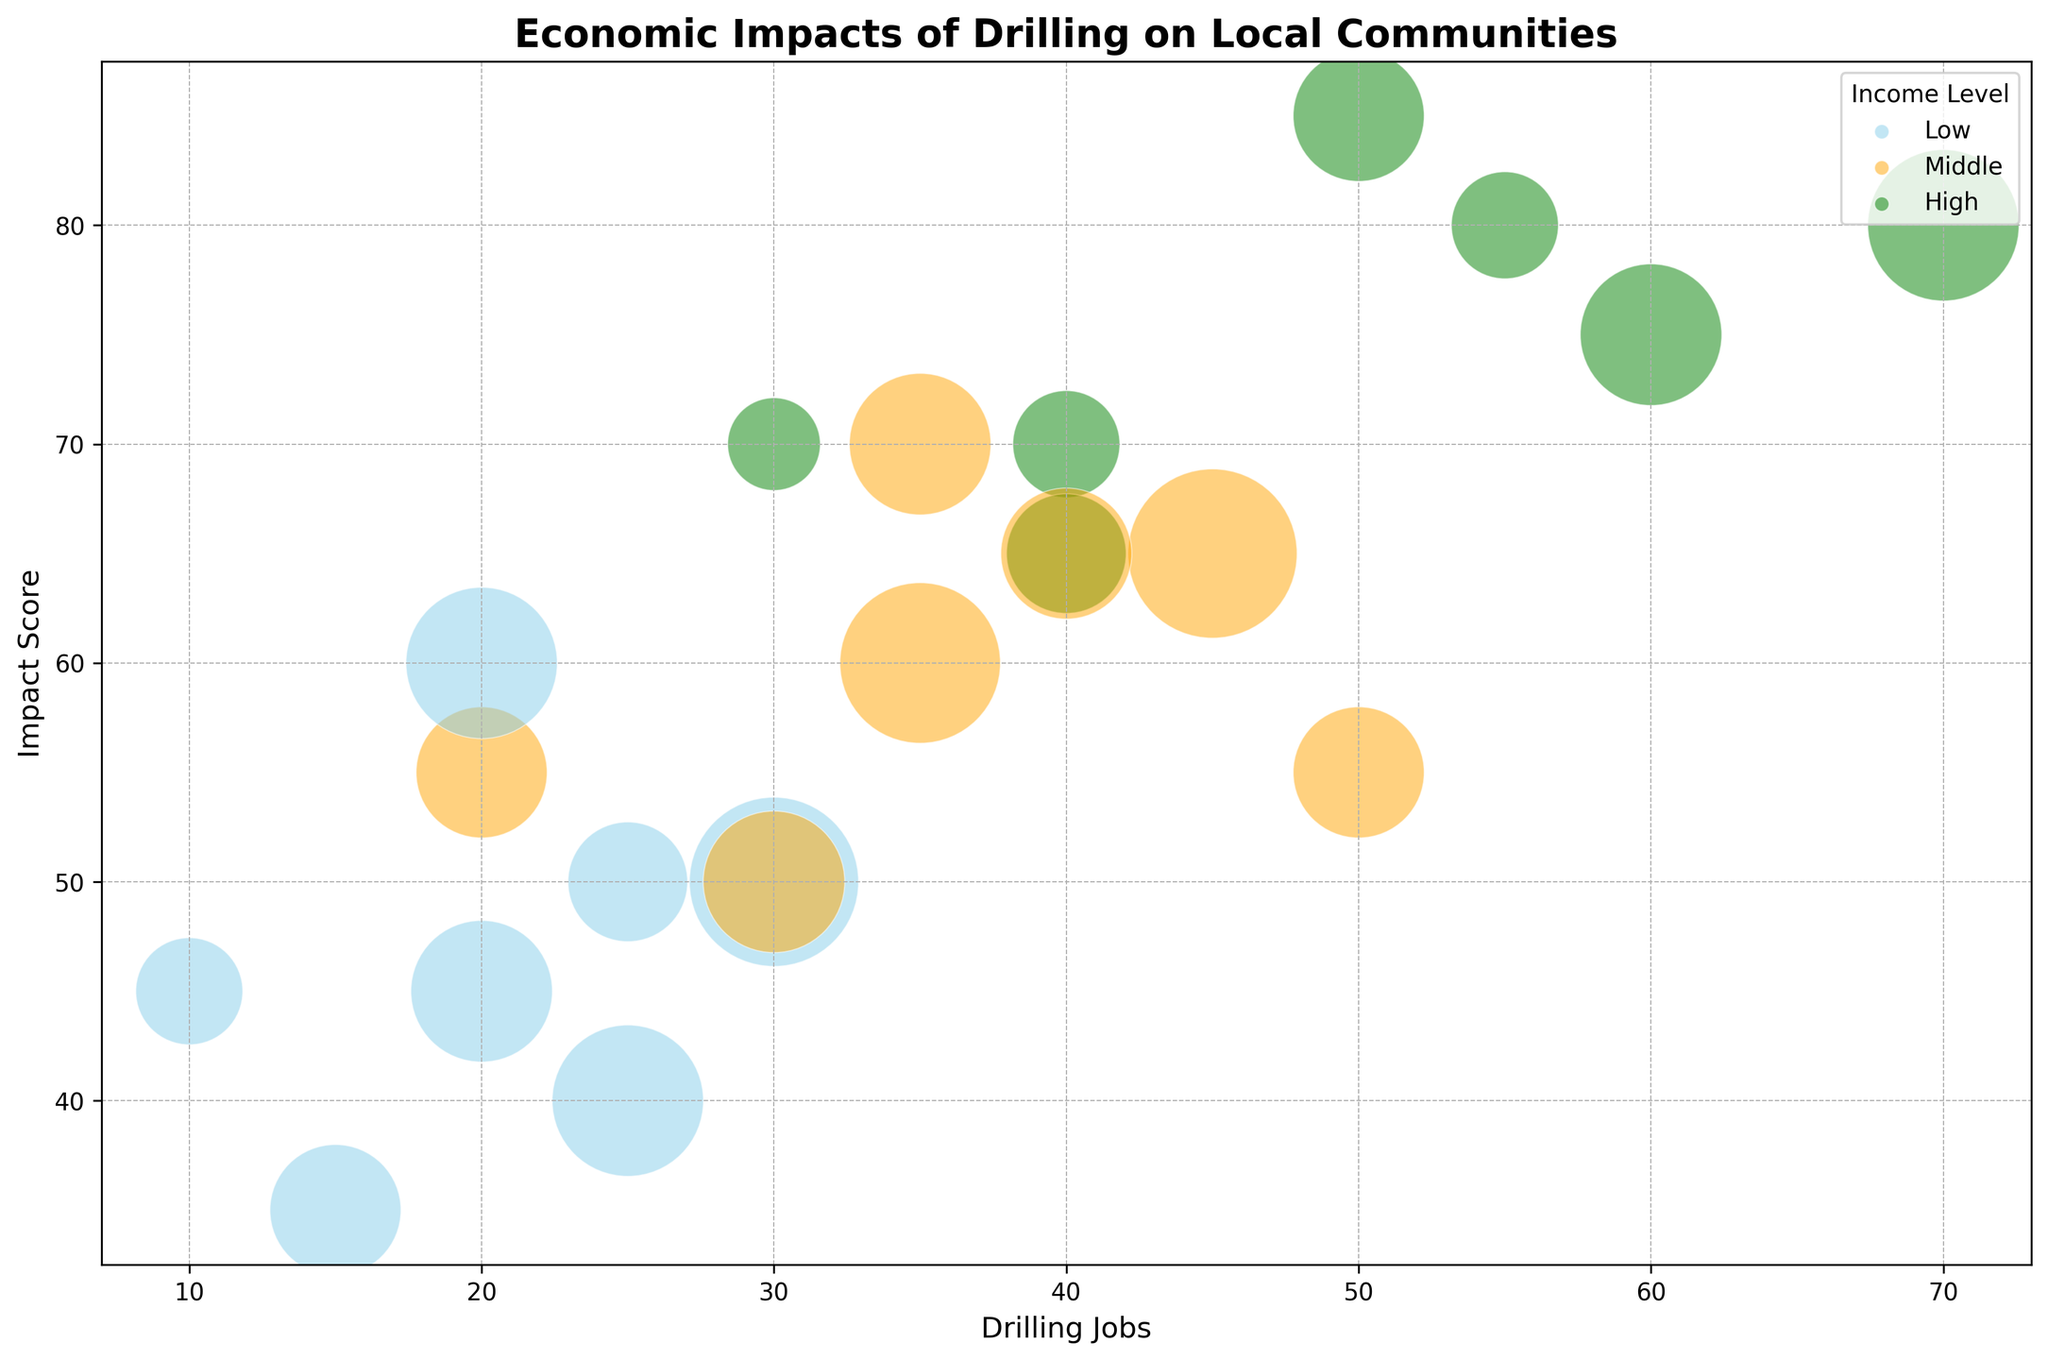What's the primary visual difference between data points representing low-income levels and high-income levels? The data points representing low-income levels are colored in sky blue, while those representing high-income levels are colored in green. This color coding helps quickly identify which income level each bubble corresponds to.
Answer: Color Which sector shows the highest Impact Score within the low-income level? To determine the highest Impact Score within the low-income level, locate the sky blue bubbles and compare their positions along the y-axis. The bubble for Manufacturing is the highest at an Impact Score of 50.
Answer: Manufacturing In the middle-income level, which sector has the fewest Drilling Jobs? To find the sector with the fewest Drilling Jobs in the middle-income level, look at the orange bubbles and compare their positions along the x-axis. The bubble for Education is situated the farthest to the left at 20 Drilling Jobs.
Answer: Education Compare the Impact Scores of the Healthcare sector across all income levels. To compare the Impact Scores for the Healthcare sector, find the corresponding bubbles colored in sky blue (Low), orange (Middle), and green (High). The Impact Scores are 50 for Low, 65 for Middle, and 80 for High income levels.
Answer: 50 (Low), 65 (Middle), 80 (High) Which bubble represents the largest population affected in the dataset, and what income level does it belong to? The largest bubble corresponds to the largest sizing, representing the highest population affected. The largest bubble is green, indicating it belongs to the high-income level, specifically in the Manufacturing sector.
Answer: High, Manufacturing What is the approximate average Impact Score for the Retail Trade sector across all income levels? To find the average Impact Score for the Retail Trade sector, locate the bubbles for Retail Trade in sky blue, orange, and green. Their Impact Scores are 40, 60, and 75. The average is (40 + 60 + 75) / 3 = 58.33.
Answer: 58.33 Between Retail Trade and Healthcare sectors in high-income levels, which one has more Drilling Jobs? Comparing the green bubbles for Retail Trade and Healthcare, look at their positions along the x-axis. Retail Trade has 60 Drilling Jobs, while Healthcare has 55 Drilling Jobs. Retail Trade has more.
Answer: Retail Trade For which income level is the Agriculture sector's Impact Score the highest and how much is it? To find the highest Impact Score for the Agriculture sector, compare the blue, orange, and green bubbles. The green (high-income level) bubble is the highest, with an Impact Score of 70.
Answer: High, 70 Which sector within the middle-income level has the smallest population affected by drilling? Locate the orange bubbles and compare their sizes. The smallest bubble belongs to the Education sector with 300 people affected.
Answer: Education 